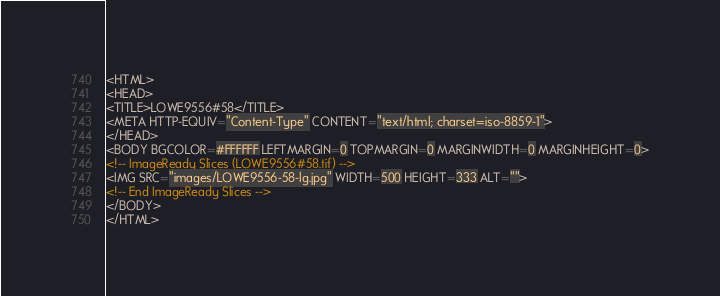<code> <loc_0><loc_0><loc_500><loc_500><_HTML_><HTML>
<HEAD>
<TITLE>LOWE9556#58</TITLE>
<META HTTP-EQUIV="Content-Type" CONTENT="text/html; charset=iso-8859-1">
</HEAD>
<BODY BGCOLOR=#FFFFFF LEFTMARGIN=0 TOPMARGIN=0 MARGINWIDTH=0 MARGINHEIGHT=0>
<!-- ImageReady Slices (LOWE9556#58.tif) -->
<IMG SRC="images/LOWE9556-58-lg.jpg" WIDTH=500 HEIGHT=333 ALT="">
<!-- End ImageReady Slices -->
</BODY>
</HTML></code> 